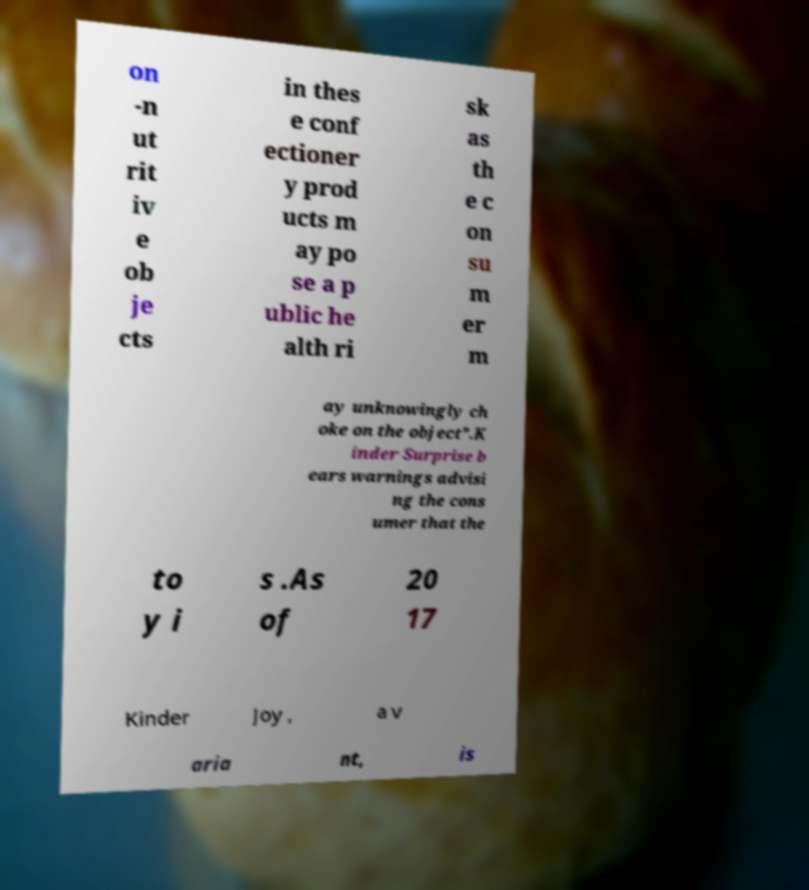I need the written content from this picture converted into text. Can you do that? on -n ut rit iv e ob je cts in thes e conf ectioner y prod ucts m ay po se a p ublic he alth ri sk as th e c on su m er m ay unknowingly ch oke on the object”.K inder Surprise b ears warnings advisi ng the cons umer that the to y i s .As of 20 17 Kinder Joy , a v aria nt, is 